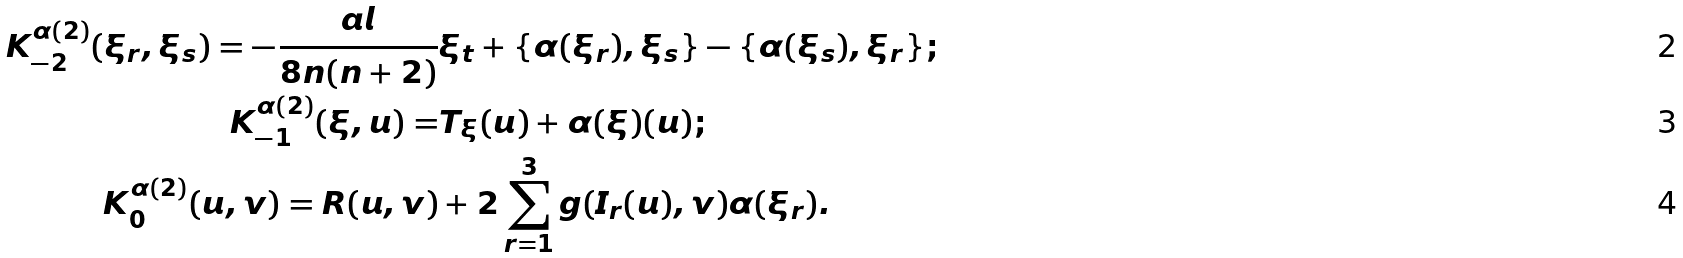<formula> <loc_0><loc_0><loc_500><loc_500>K ^ { \alpha ( 2 ) } _ { - 2 } ( \xi _ { r } , \xi _ { s } ) = - \frac { a l } { 8 n ( n + 2 ) } & \xi _ { t } + \{ \alpha ( \xi _ { r } ) , \xi _ { s } \} - \{ \alpha ( \xi _ { s } ) , \xi _ { r } \} ; \\ K ^ { \alpha ( 2 ) } _ { - 1 } ( \xi , u ) = & T _ { \xi } ( u ) + \alpha ( \xi ) ( u ) ; \\ K ^ { \alpha ( 2 ) } _ { 0 } ( u , v ) = R ( u , v ) & + 2 \sum _ { r = 1 } ^ { 3 } g ( I _ { r } ( u ) , v ) \alpha ( \xi _ { r } ) .</formula> 